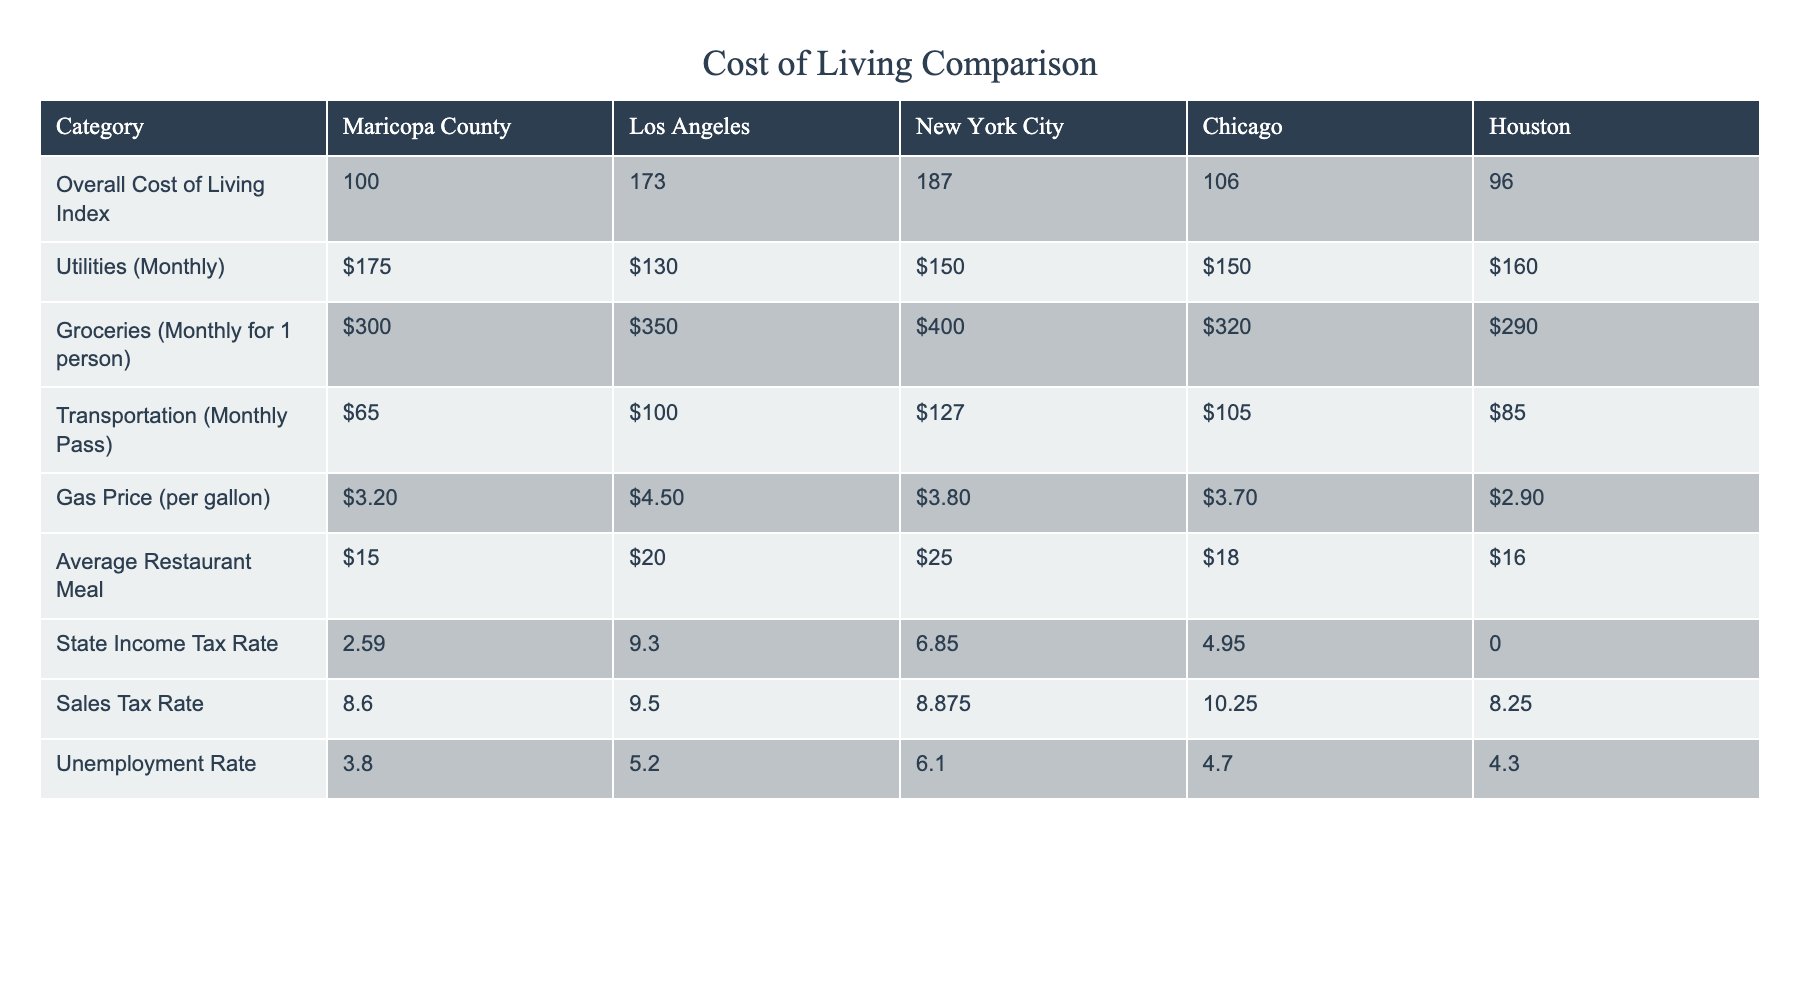What is the overall cost of living index in Maricopa County? The overall cost of living index for Maricopa County is listed directly in the table. It shows a value of 100.
Answer: 100 Which city has the highest transportation monthly pass cost? By comparing the transportation monthly pass costs across the cities, Los Angeles has the highest cost at $100.
Answer: Los Angeles What is the difference in the average restaurant meal cost between Maricopa County and New York City? The average restaurant meal cost in Maricopa County is $15, while in New York City it is $25. The difference is $25 - $15 = $10.
Answer: $10 Is the unemployment rate in Maricopa County lower than that in Chicago? The unemployment rate for Maricopa County is 3.8%, while for Chicago it is 4.7%. Since 3.8% is less than 4.7%, the statement is true.
Answer: Yes What percentage of sales tax does Maricopa County have compared to Houston? Maricopa County has a sales tax rate of 8.6%, while Houston has 8.25%. The difference is 8.6% - 8.25% = 0.35%, showing Maricopa has a higher rate.
Answer: 0.35% What is the average price of gas between Maricopa County and Los Angeles? The gas price in Maricopa County is $3.20 and in Los Angeles it is $4.50. The average price is ($3.20 + $4.50) / 2 = $3.85.
Answer: $3.85 If you were to combine the utilities and groceries costs for Maricopa County, what would that total be? The utilities cost in Maricopa County is $175 and groceries cost $300. Adding these together gives a total of $175 + $300 = $475.
Answer: $475 Which city has a lower state income tax rate: Maricopa County or New York City? Maricopa County's state income tax rate is 2.59%, while New York City's is 6.85%. Therefore, Maricopa County has a lower rate.
Answer: Yes What is the average unemployment rate from the listed metropolitan areas? The unemployment rates are 3.8%, 5.2%, 6.1%, 4.7%, and 4.3%. First sum them: 3.8 + 5.2 + 6.1 + 4.7 + 4.3 = 24.1. Then divide by 5 to find the average: 24.1 / 5 = 4.82%.
Answer: 4.82% 